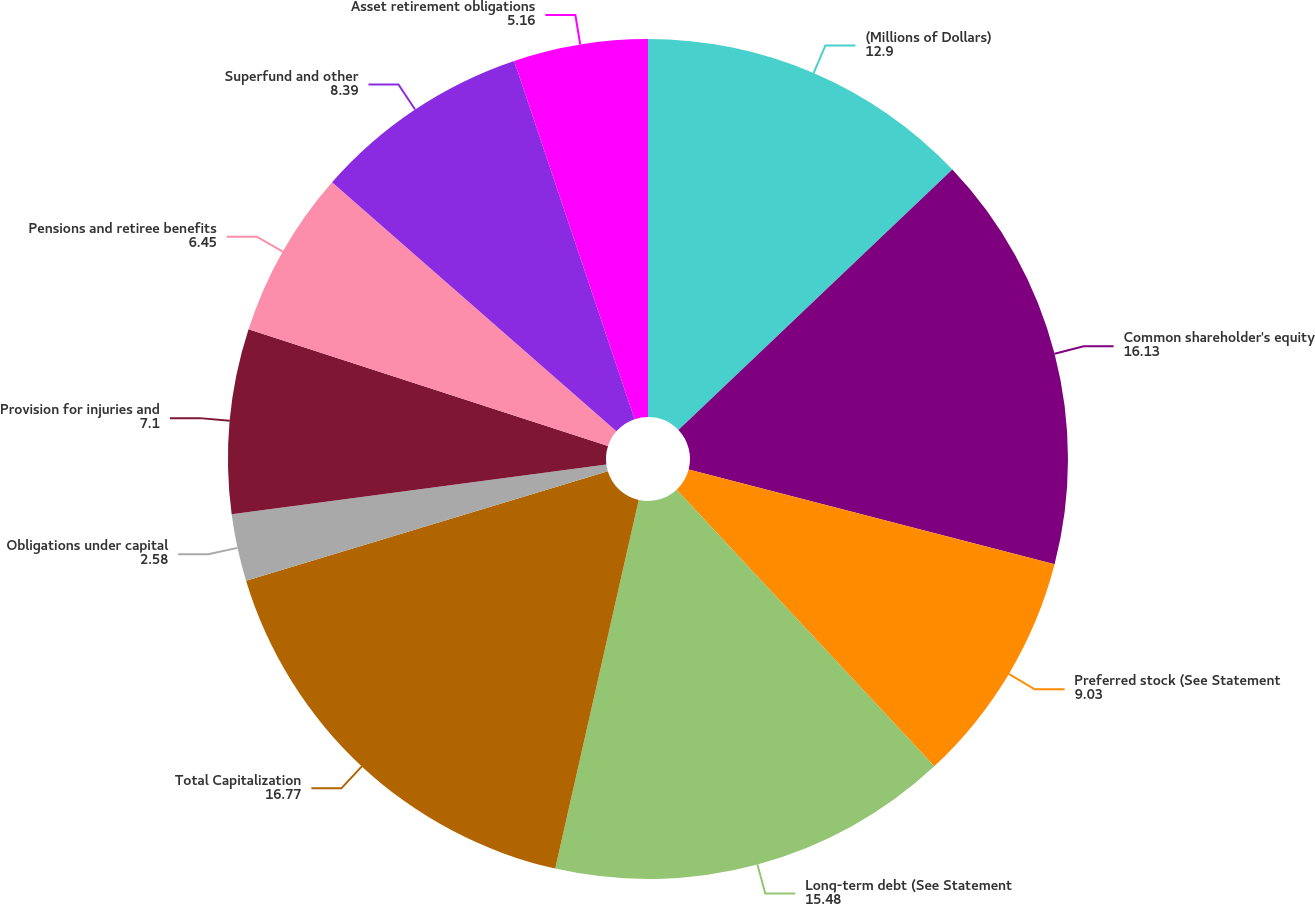Convert chart to OTSL. <chart><loc_0><loc_0><loc_500><loc_500><pie_chart><fcel>(Millions of Dollars)<fcel>Common shareholder's equity<fcel>Preferred stock (See Statement<fcel>Long-term debt (See Statement<fcel>Total Capitalization<fcel>Obligations under capital<fcel>Provision for injuries and<fcel>Pensions and retiree benefits<fcel>Superfund and other<fcel>Asset retirement obligations<nl><fcel>12.9%<fcel>16.13%<fcel>9.03%<fcel>15.48%<fcel>16.77%<fcel>2.58%<fcel>7.1%<fcel>6.45%<fcel>8.39%<fcel>5.16%<nl></chart> 